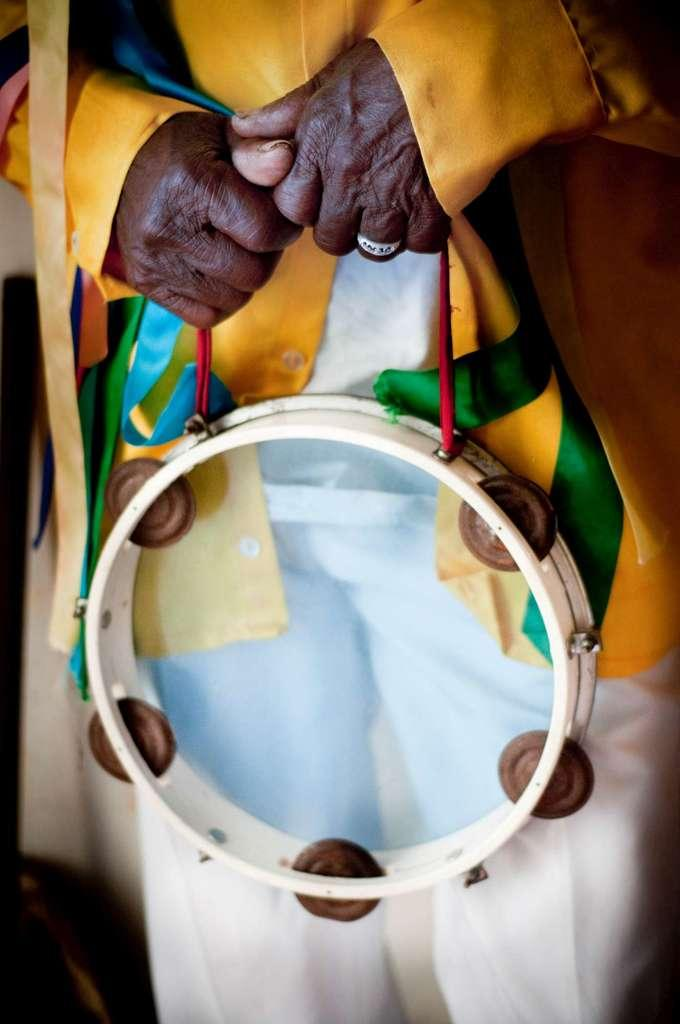What is the main subject of the image? There is a person in the image. What is the person doing in the image? The person is holding a musical instrument. What type of territory is being claimed by the person in the image? There is no indication of territory being claimed in the image; the person is simply holding a musical instrument. How many crates are visible in the image? There are no crates present in the image. 